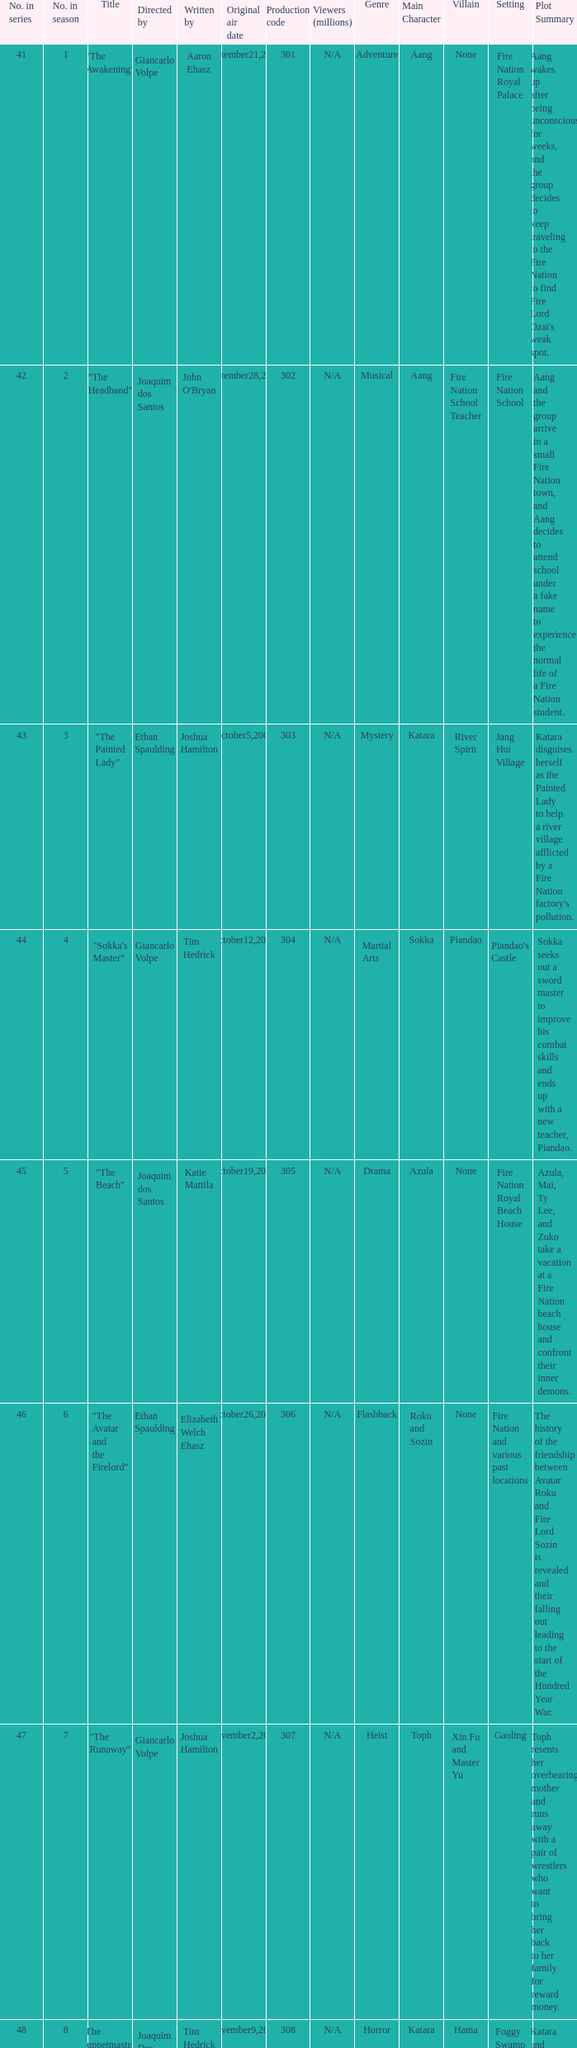What is the original air date for the episode with a production code of 318? July19,2008. 